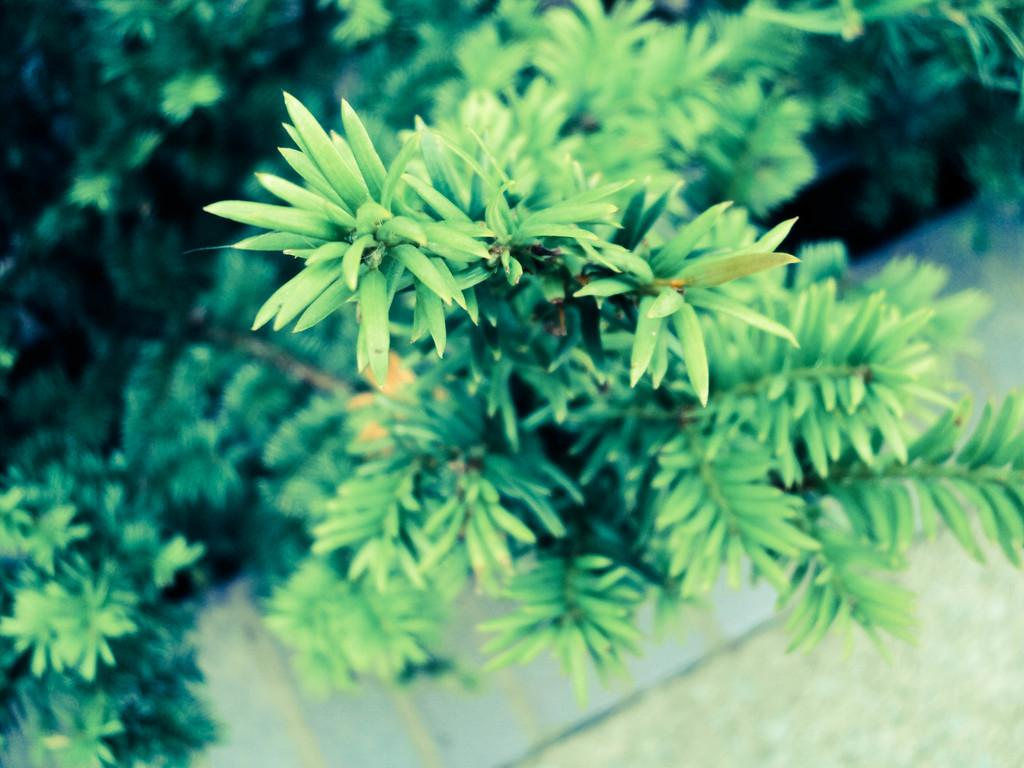What type of vegetation can be seen in the image? There are trees in the image. What is the color of the trees in the image? The trees are green in color. How many balls are visible in the image? There are no balls present in the image. What is the limit of the trees in the image? The trees in the image do not have a limit; they are depicted within the boundaries of the image. 